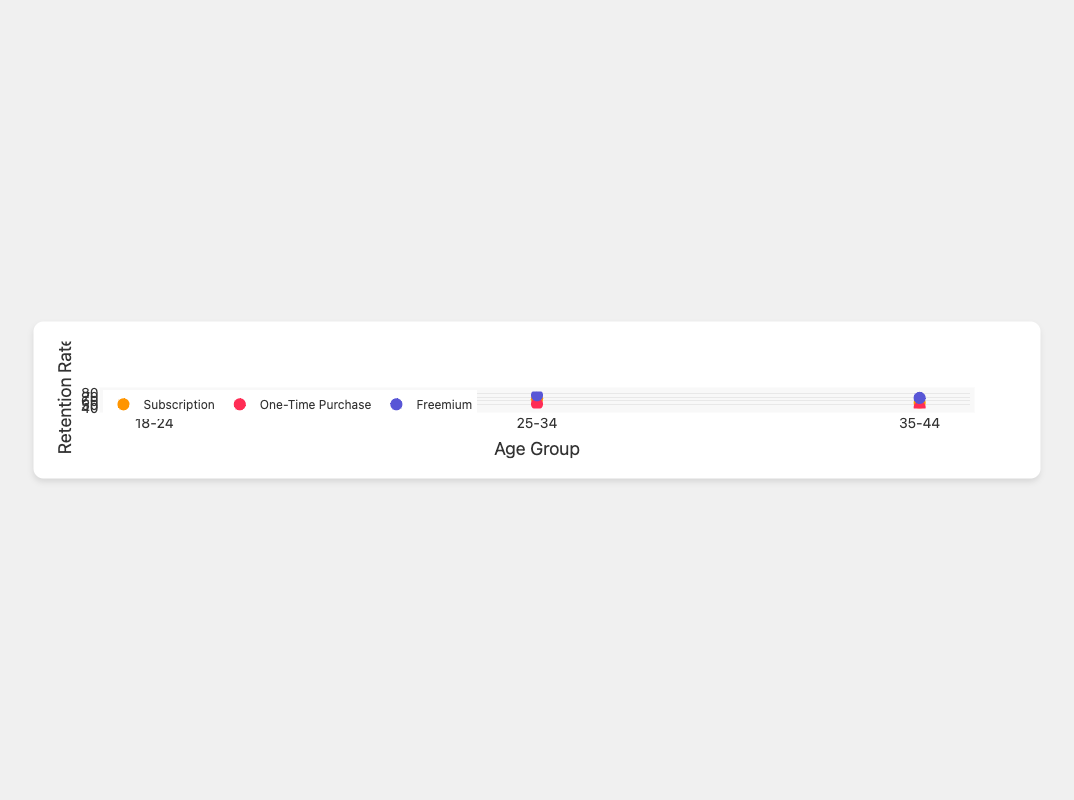How many age groups are present in the figure? The x-axis of the figure lists distinct age groups. We count them to determine the number of groups. The groups are "18-24", "25-34", and "35-44".
Answer: 3 What is the user retention rate for the "Fitness Pro" app with a subscription model in the age group 18-24? Locate the data point for "Fitness Pro" with a subscription model, then refer to the marker positioned over the "18-24" label on the x-axis. The corresponding y-value provides the retention rate.
Answer: 72% Which app has the highest user retention rate for users aged 18-24? Locate all data points for the age group "18-24" and compare their y-values. The "Social Buzz" app with the Freemium model has the highest y-value for this group.
Answer: Social Buzz What is the difference in user retention rates between the "Social Buzz" and "Cooking Stars" apps for users aged 25-34? Identify the marker for "Social Buzz" in the age group "25-34" and note its y-value. Do the same for "Cooking Stars" in the same age group. Subtract the retention rate of "Cooking Stars" from that of "Social Buzz".
Answer: 75% - 60% = 15% Which in-app purchase model generally shows the highest user retention rates? Compare the average user retention rates for all age groups combined for each purchase model. The Freemium model appears to show higher y-values consistently compared to the others.
Answer: Freemium How does the user retention rate for the "Travel Guide" app change across age groups? Observe the markers for the "Travel Guide" app across different age groups. The retention rates for "Travel Guide" are 65% (18-24), 68% (25-34), and 55% (35-44).
Answer: Drops from 68% in the age group 25-34 to 55% in the age group 35-44 Is the user retention rate higher for "One-Time Purchase" models or "Subscription" models in the age group 25-34? Compare the retention rates for "One-Time Purchase" models (e.g., "Puzzle Master" and "Meditation Moments") and "Subscription" models (e.g., "Fitness Pro" and "Travel Guide") in the age group "25-34". The "Subscription" models generally have higher rates.
Answer: Subscription How many markers represent an in-app purchase model in the figure? Purchase models in the figure are divided into categories such as "Freemium", "One-Time Purchase", and "Subscription". Count the markers corresponding to each category to determine the total number representing in-app purchase models. Each purchase model has 6 markers.
Answer: 6 markers per model What is the average user retention rate for the "Freemium" model in the age group 18-24? Add the user retention rates of the "Freemium" apps ("Social Buzz" and "Cooking Stars") in the age group "18-24" and divide by the number of apps. The rates are 80% and 69% respectively.
Answer: (80% + 69%) / 2 = 74.5% 